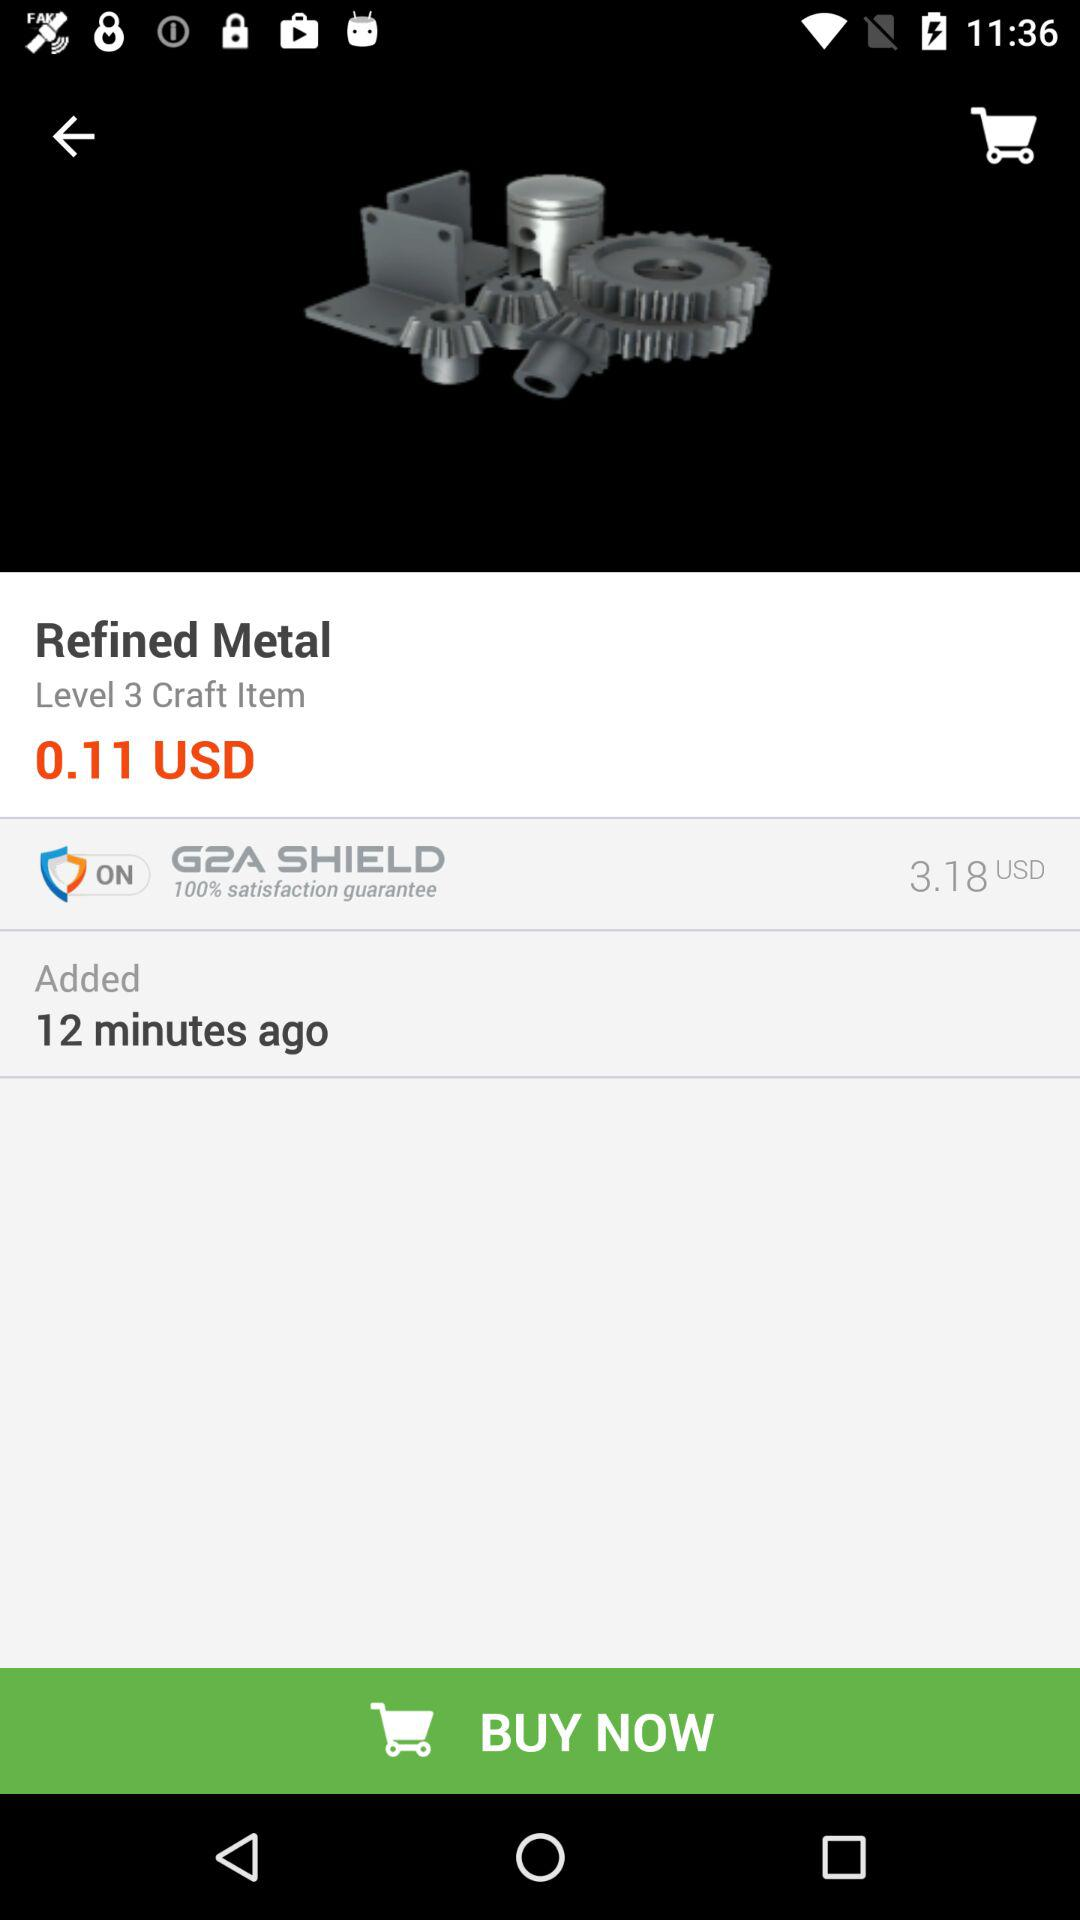How many US dollars are there for the G2A shield? There are 3.18 USD. 